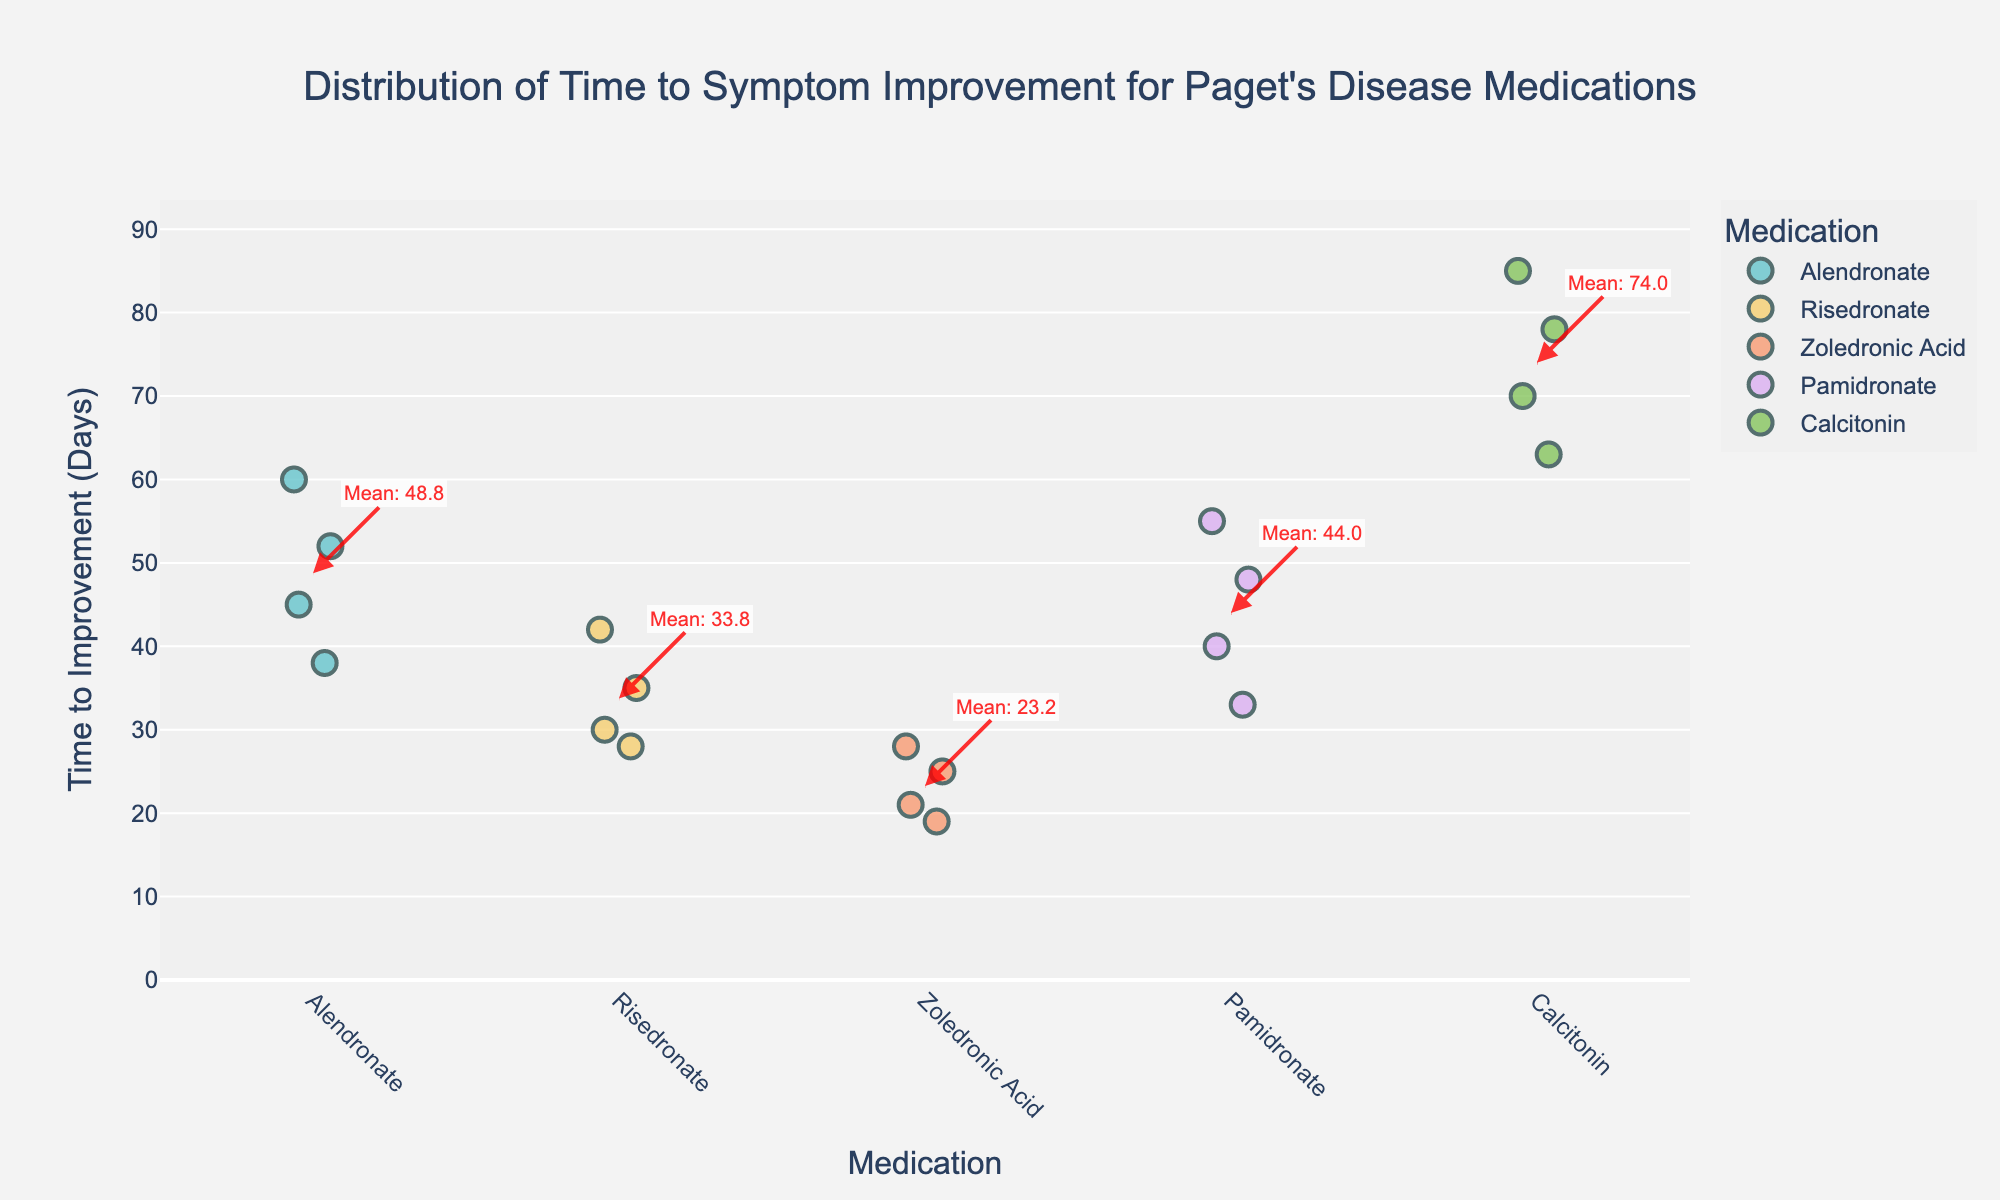How many medications are compared in the strip plot? There are 6 different medications listed along the x-axis: Alendronate, Risedronate, Zoledronic Acid, Pamidronate, and Calcitonin.
Answer: 5 Which medication shows the shortest time to symptom improvement? By examining the y-axis values, Zoledronic Acid has the shortest time to symptom improvement, with the smallest value being 19 days.
Answer: Zoledronic Acid Which medication has the longest mean time to improvement according to the annotations? The annotations on the plot indicate the mean time to improvement for each medication. The medication with the mean time closest to the top of the y-axis is Calcitonin.
Answer: Calcitonin What is the mean time to improvement for Risedronate? The annotation for Risedronate shows the mean time, which is marked by a red dotted line. The value stated in the annotation is approximately 33.8 days.
Answer: 33.8 days How many patients' data are represented for Pamidronate? By counting the individual points along the strip plot for Pamidronate, there are 4 data points.
Answer: 4 Which medication demonstrates the highest variability in time to improvement? By observing the spread of data points on the y-axis for each medication, Calcitonin shows the widest spread from 63 to 85 days, indicating the highest variability.
Answer: Calcitonin Do any medications have overlapping time to improvement ranges? Comparing the vertical spreads of dots for each medication group, there is an overlap in the ranges for Alendronate and Pamidronate, both varying between around 30 to 60 days.
Answer: Yes, Alendronate and Pamidronate How does the range of improvement times for Zoledronic Acid compare to that of Calcitonin? Zoledronic Acid ranges from 19 to 28 days, while Calcitonin ranges from 63 to 85 days. This shows that Zoledronic Acid has a much narrower and lower range compared to Calcitonin.
Answer: Zoledronic Acid has a narrower and lower range What is the approximate time gap between the shortest and longest time to improvement for Alendronate? Analyzing the y-axis values for Alendronate, the shortest time is 38 days, and the longest is 60 days. The difference is 60 - 38 = 22 days.
Answer: 22 days 